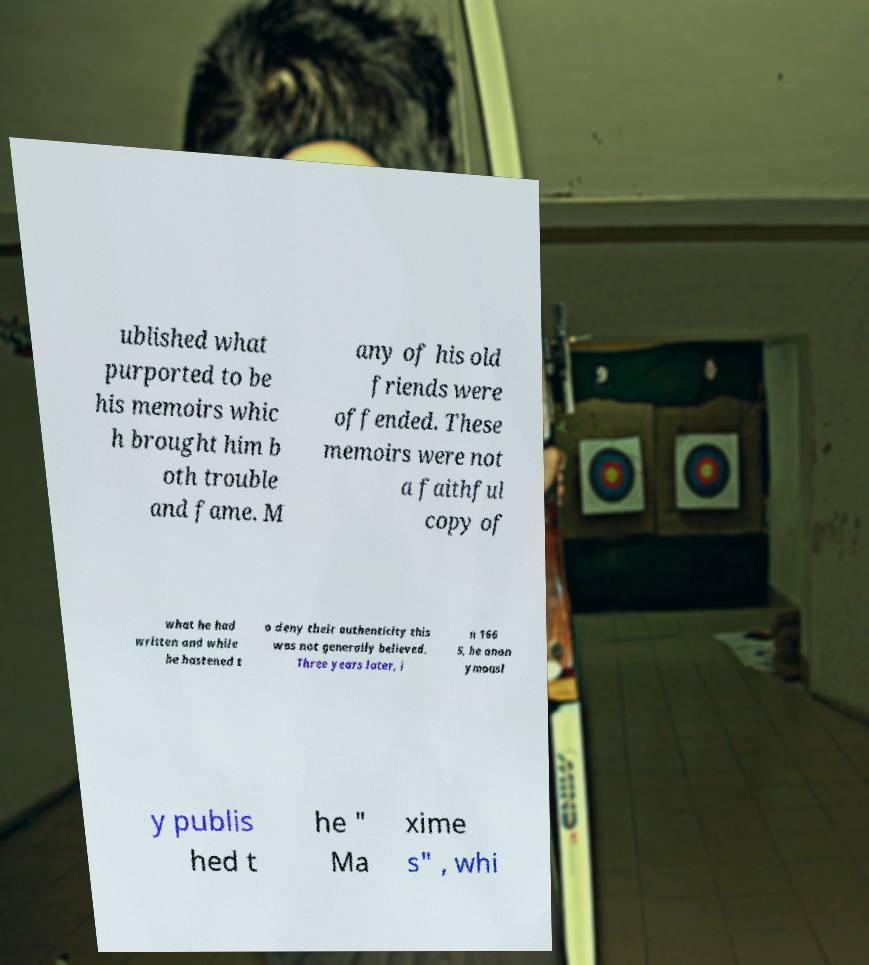Could you extract and type out the text from this image? ublished what purported to be his memoirs whic h brought him b oth trouble and fame. M any of his old friends were offended. These memoirs were not a faithful copy of what he had written and while he hastened t o deny their authenticity this was not generally believed. Three years later, i n 166 5, he anon ymousl y publis hed t he " Ma xime s" , whi 